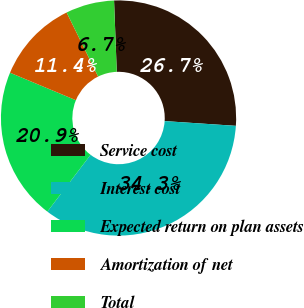Convert chart. <chart><loc_0><loc_0><loc_500><loc_500><pie_chart><fcel>Service cost<fcel>Interest cost<fcel>Expected return on plan assets<fcel>Amortization of net<fcel>Total<nl><fcel>26.67%<fcel>34.29%<fcel>20.95%<fcel>11.43%<fcel>6.67%<nl></chart> 